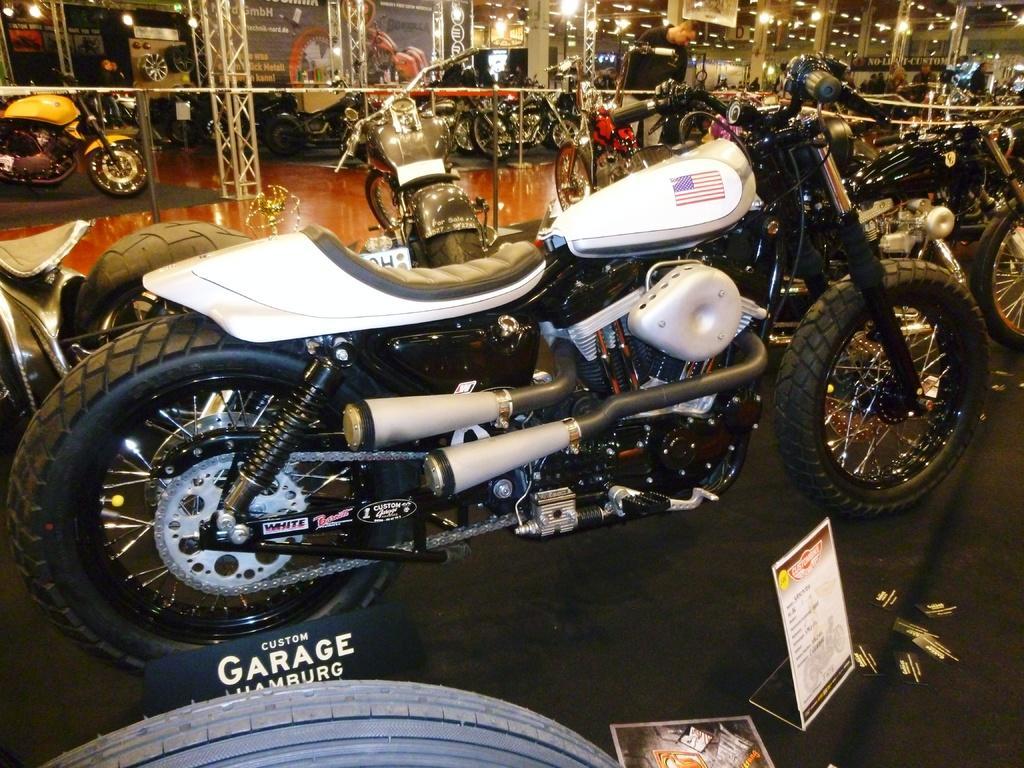Please provide a concise description of this image. In this image we can see some motorbikes and the place looks like a show room and we can see some other objects. There are some lights attached to the ceiling and there is a person standing near the motorbike and in the background, we can see a board with text and picture. 